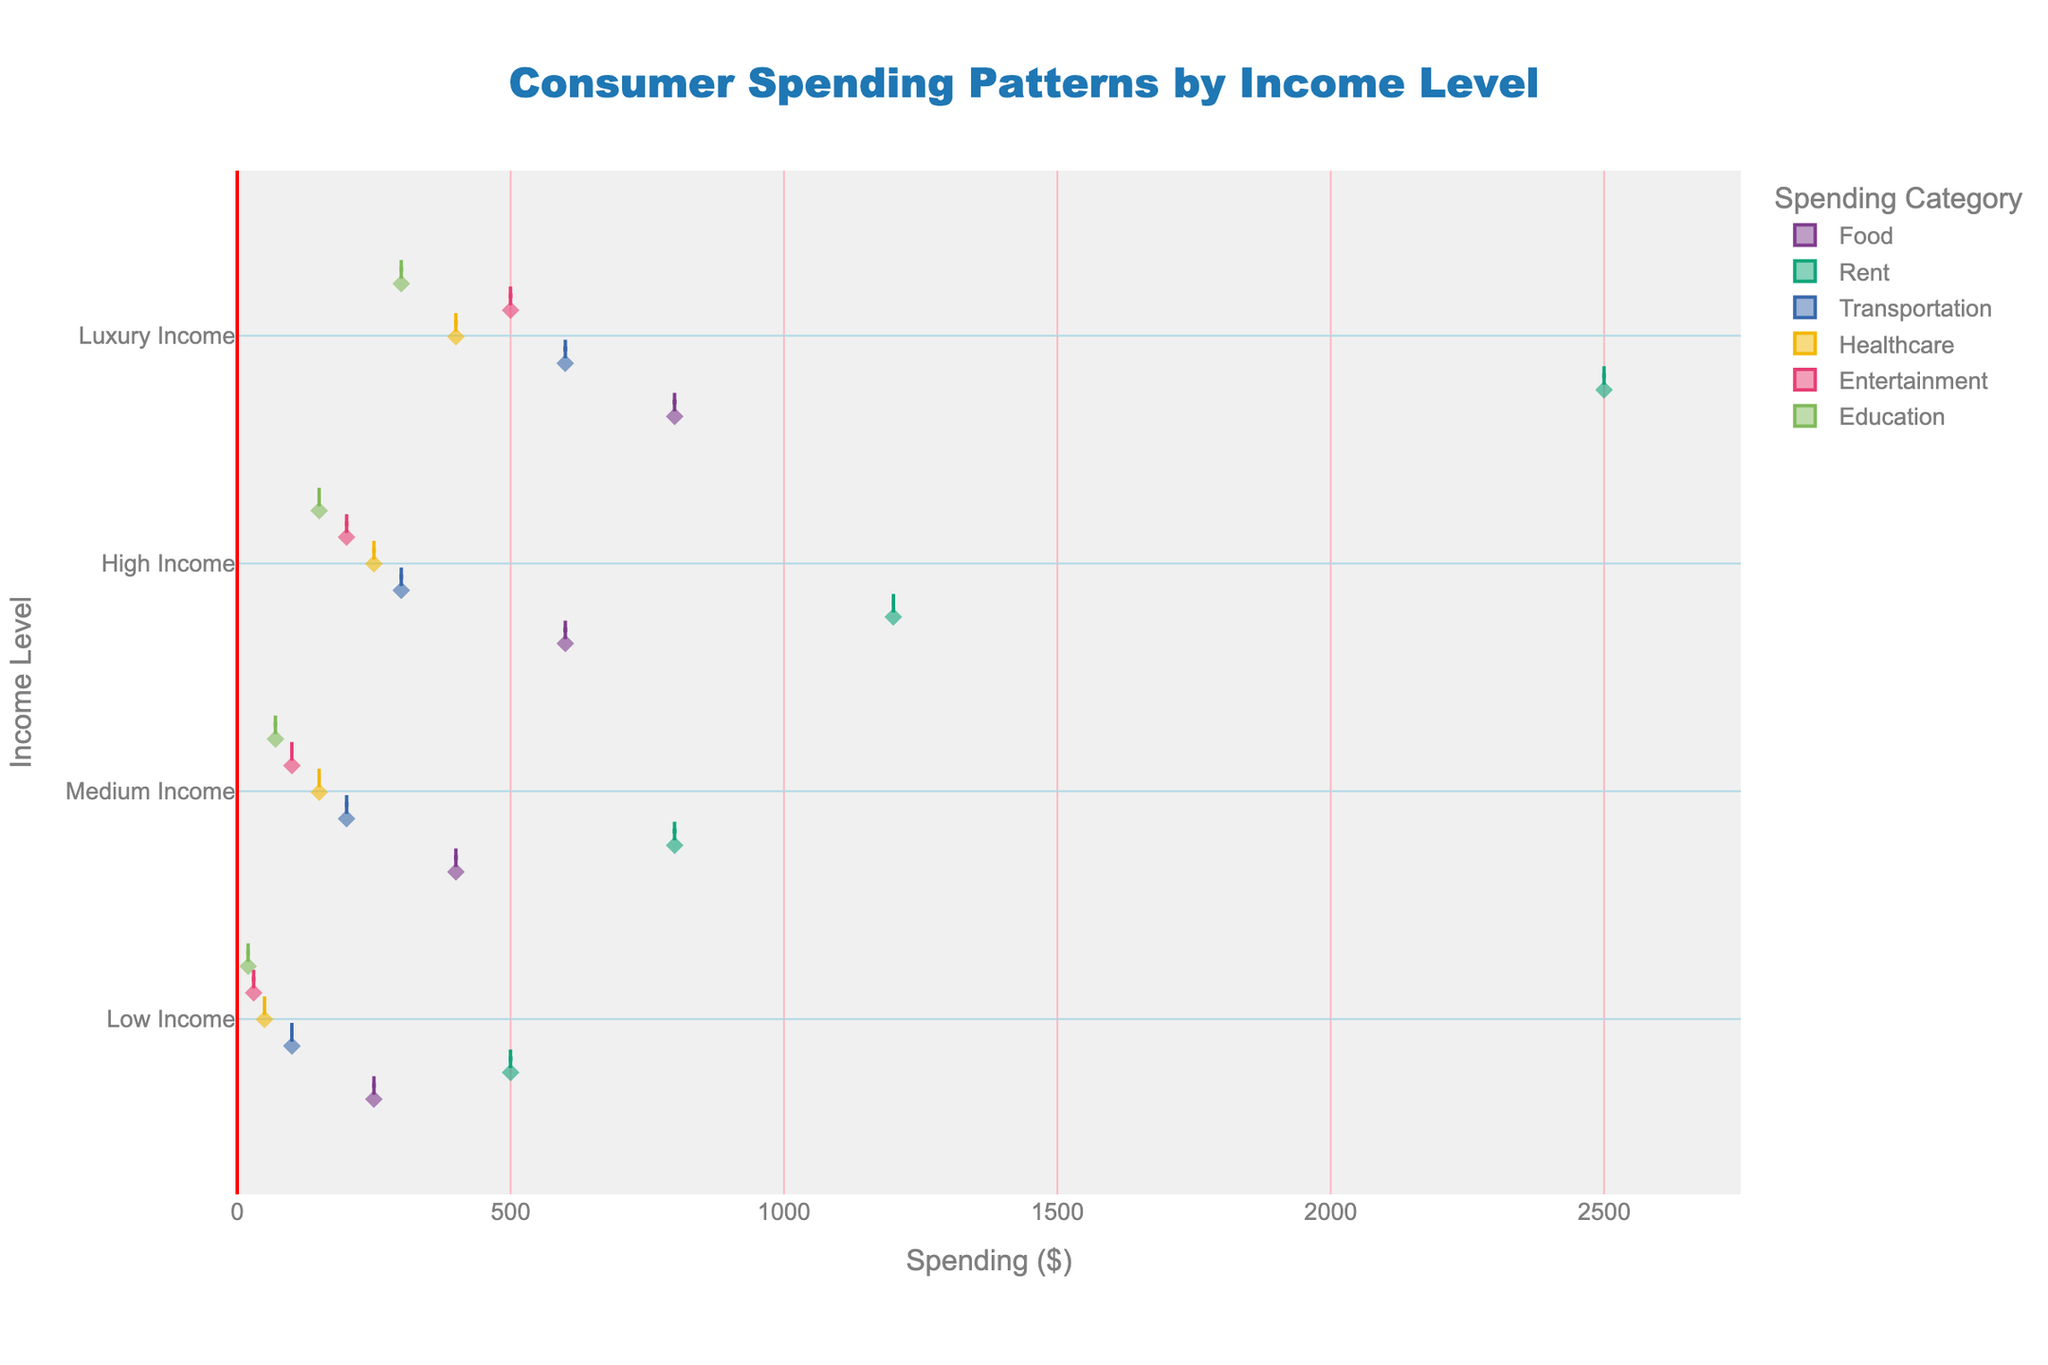What is the title of the plot? The title is located at the top-center of the plot and is commonly used to describe the plot's main idea.
Answer: Consumer Spending Patterns by Income Level How many income levels are displayed? By looking at the y-axis labels, we can count the number of distinct income levels.
Answer: Four Which spending category has the widest distribution for Luxury Income? To find this, observe the width of the violins along the x-axis at the Luxury Income level; the category with the widest width indicates the largest spread.
Answer: Rent What is the highest recorded spending value in the plot? The x-axis shows spending values, and by finding the point on the rightmost edge of the entire plot, we identify the maximum value.
Answer: $2500 Which income level shows the highest average spending on Healthcare? To determine the highest average spending, look for the meanline within each violin plot for Healthcare category across income levels and identify the highest.
Answer: Luxury Income Compare the spending on Food between Low Income and High Income levels: which is higher? By comparing the violin plots for the Food category at Low Income and High Income levels, we can see the central tendency or average spending of each level.
Answer: High Income Which category seems to have the least variation in spending for Medium Income? Observing the width of the violin plots for Medium Income, the category with the narrowest width has the least variation.
Answer: Education What is the mean (average) spending on Education for Medium Income? Using the boxplot within the Education violin for Medium Income, locate the meanline to find the average spending value.
Answer: $70 How does the spending on Transportation differ between Medium Income and High Income? By examining the violin plots for the Transportation category for these two income levels, we can compare their width and average values to note differences.
Answer: Higher for High Income Which category shows a dramatic increase in spending from Low Income to Luxury Income? Look for a category where the violin plots stretch significantly higher across these income levels, indicating a sharp upward trend in spending.
Answer: Rent 